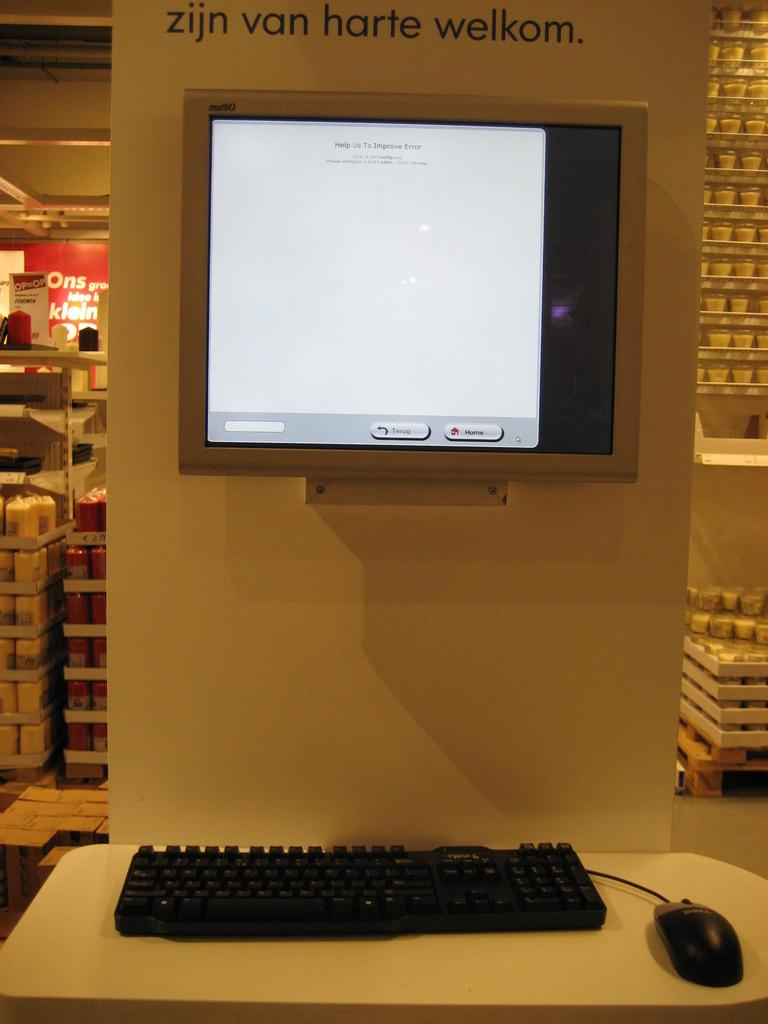<image>
Offer a succinct explanation of the picture presented. A keyboard with a mounted screen above it showing a home icon. 